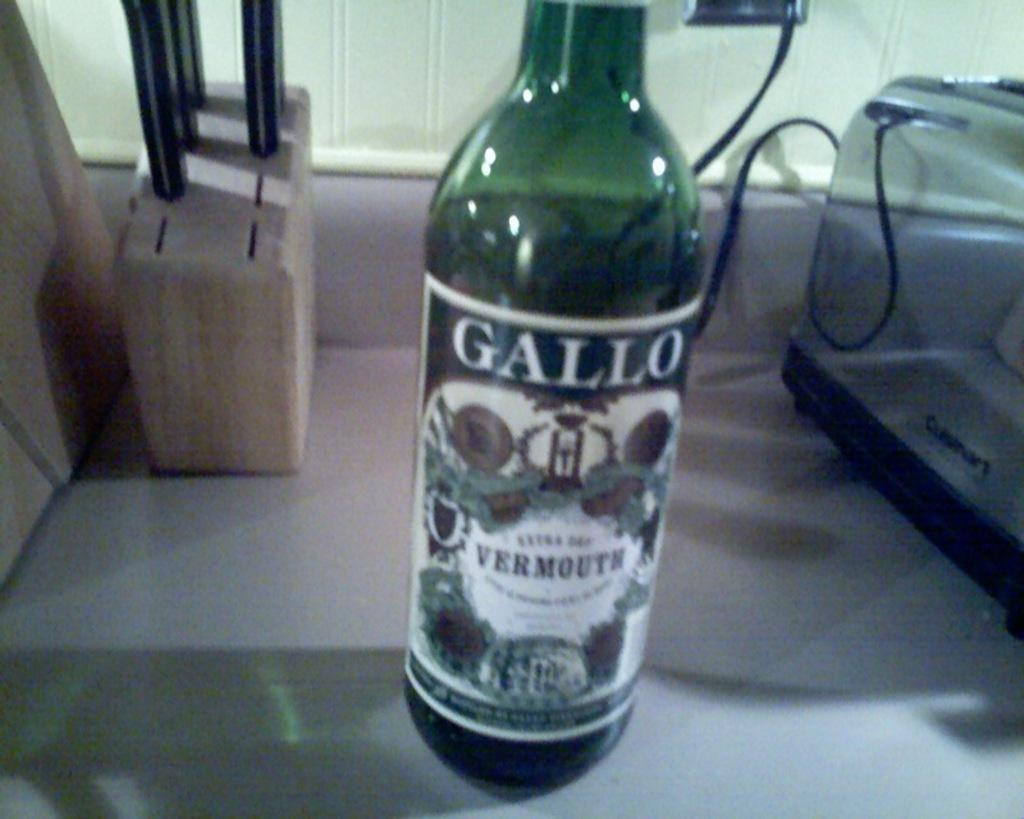<image>
Offer a succinct explanation of the picture presented. A green bottle of Gallo Extra Dry Vermouth sitting on a kitchen counter. 